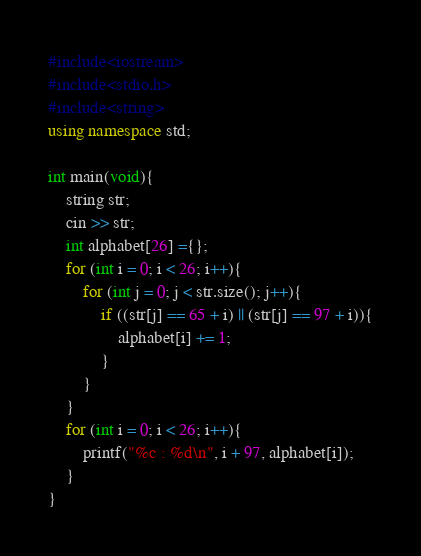<code> <loc_0><loc_0><loc_500><loc_500><_C++_>#include<iostream>
#include<stdio.h>
#include<string>
using namespace std;

int main(void){
    string str;
    cin >> str;
    int alphabet[26] ={};
    for (int i = 0; i < 26; i++){
        for (int j = 0; j < str.size(); j++){
            if ((str[j] == 65 + i) || (str[j] == 97 + i)){
                alphabet[i] += 1;
            }
        }
    }
    for (int i = 0; i < 26; i++){
        printf("%c : %d\n", i + 97, alphabet[i]);
    }
}
</code> 